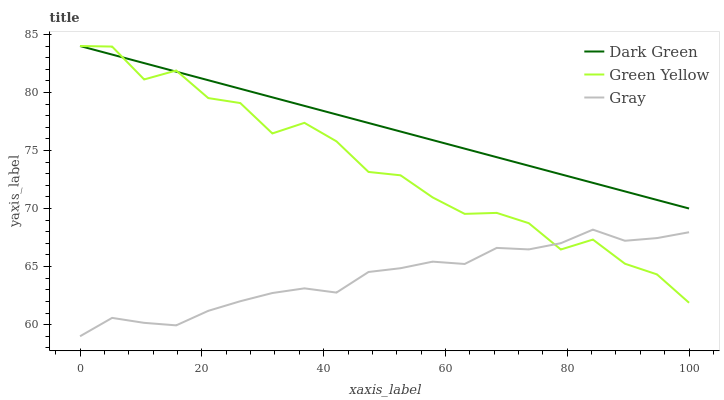Does Gray have the minimum area under the curve?
Answer yes or no. Yes. Does Dark Green have the maximum area under the curve?
Answer yes or no. Yes. Does Green Yellow have the minimum area under the curve?
Answer yes or no. No. Does Green Yellow have the maximum area under the curve?
Answer yes or no. No. Is Dark Green the smoothest?
Answer yes or no. Yes. Is Green Yellow the roughest?
Answer yes or no. Yes. Is Green Yellow the smoothest?
Answer yes or no. No. Is Dark Green the roughest?
Answer yes or no. No. Does Gray have the lowest value?
Answer yes or no. Yes. Does Green Yellow have the lowest value?
Answer yes or no. No. Does Dark Green have the highest value?
Answer yes or no. Yes. Is Gray less than Dark Green?
Answer yes or no. Yes. Is Dark Green greater than Gray?
Answer yes or no. Yes. Does Dark Green intersect Green Yellow?
Answer yes or no. Yes. Is Dark Green less than Green Yellow?
Answer yes or no. No. Is Dark Green greater than Green Yellow?
Answer yes or no. No. Does Gray intersect Dark Green?
Answer yes or no. No. 